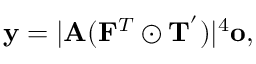Convert formula to latex. <formula><loc_0><loc_0><loc_500><loc_500>y = | A ( F ^ { T } \odot T ^ { ^ { \prime } } ) | ^ { 4 } o ,</formula> 